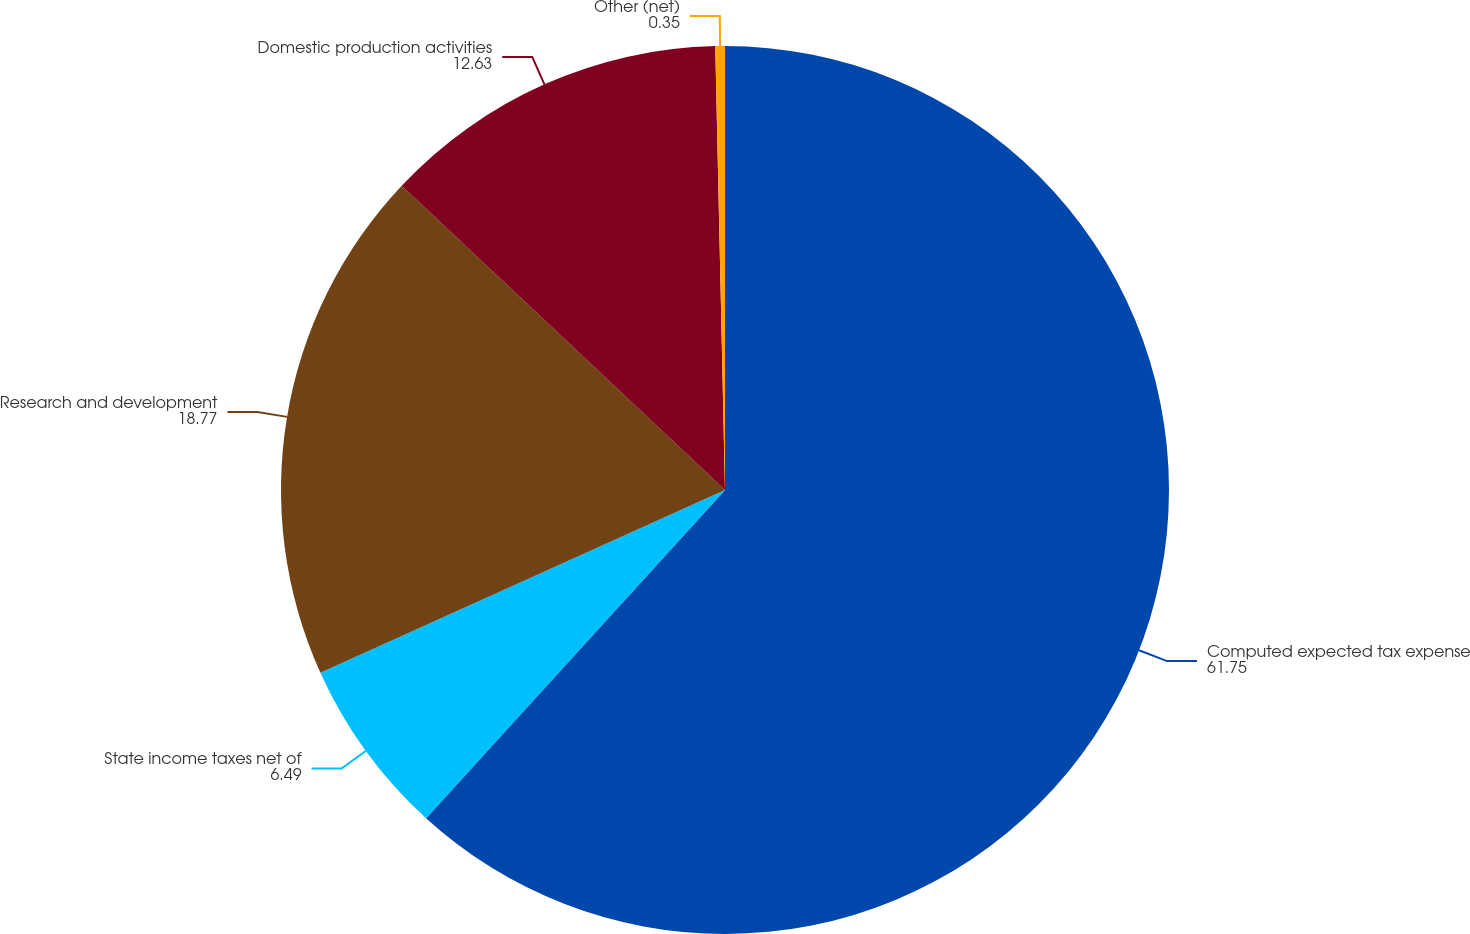<chart> <loc_0><loc_0><loc_500><loc_500><pie_chart><fcel>Computed expected tax expense<fcel>State income taxes net of<fcel>Research and development<fcel>Domestic production activities<fcel>Other (net)<nl><fcel>61.75%<fcel>6.49%<fcel>18.77%<fcel>12.63%<fcel>0.35%<nl></chart> 